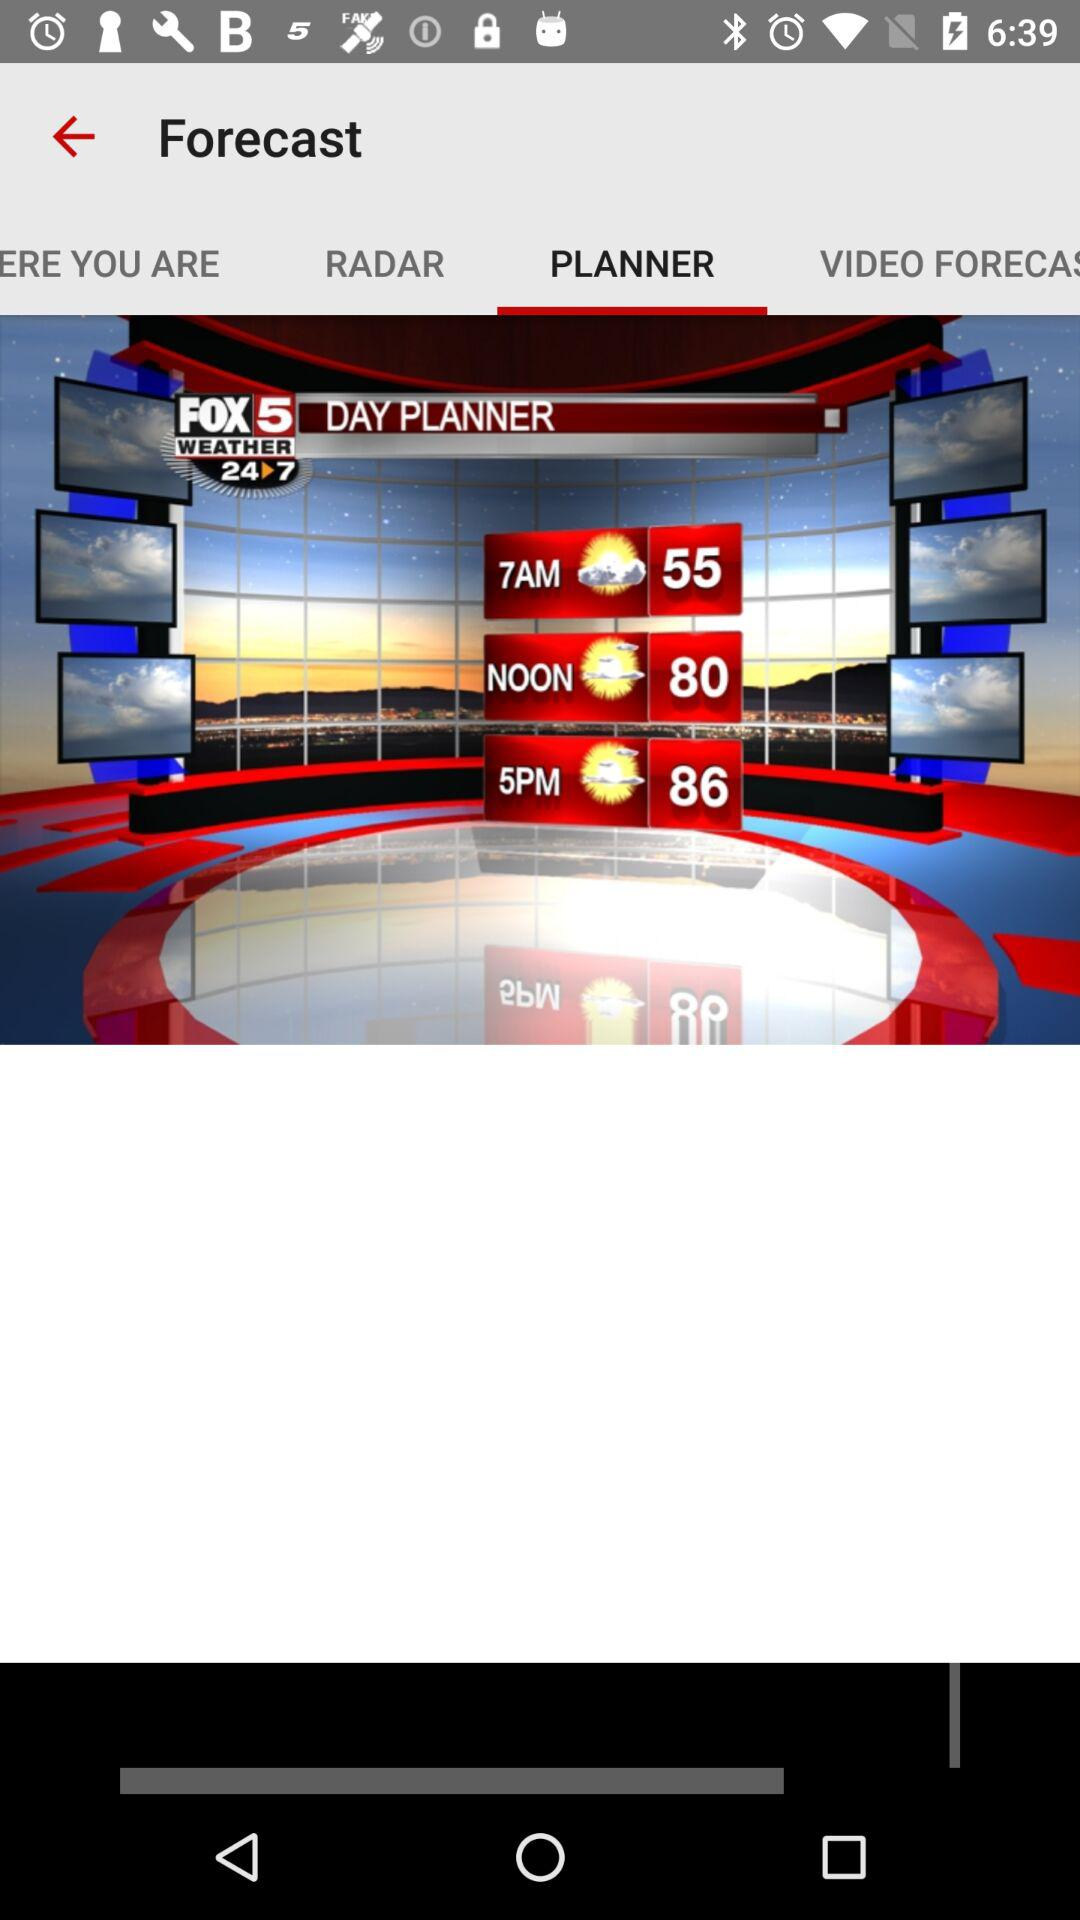How many more degrees Fahrenheit is the temperature at 5pm than the temperature at noon?
Answer the question using a single word or phrase. 6 